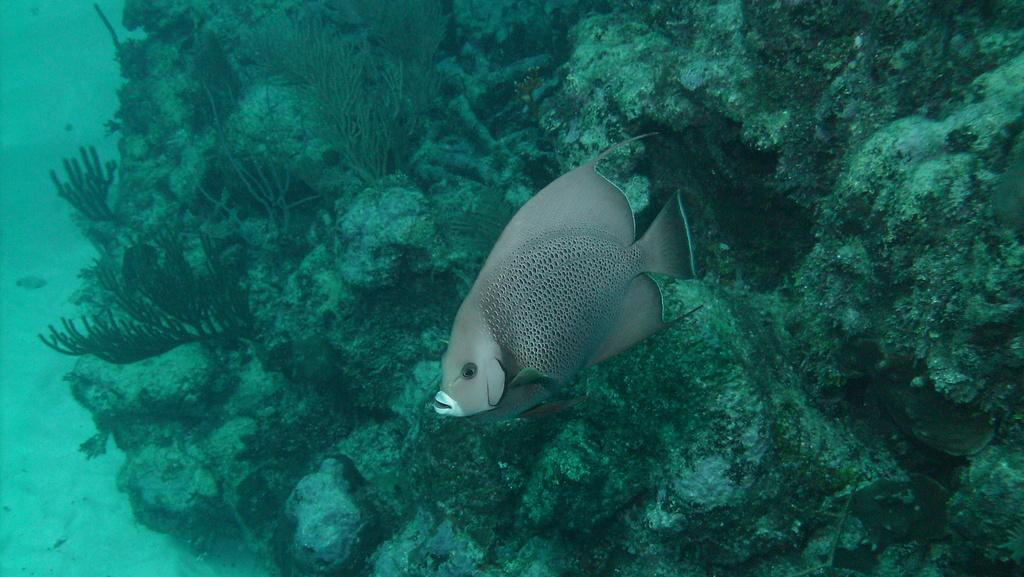What type of animals can be seen in the image? There are fish in the image. Can you describe the color of the fish? The fish is grey in color. What else can be seen in the image besides the fish? There are rocks and plants visible in the image. What type of belief system is depicted in the image? There is no indication of a belief system in the image; it features fish, rocks, and plants in a body of water. Can you tell me how many wheels are visible in the image? There are no wheels present in the image. 